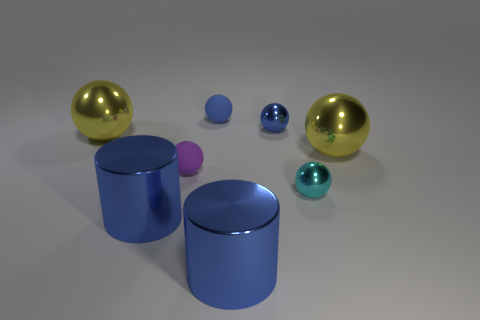Subtract 2 balls. How many balls are left? 4 Subtract all cyan spheres. How many spheres are left? 5 Subtract all blue balls. How many balls are left? 4 Subtract all gray balls. Subtract all blue blocks. How many balls are left? 6 Add 2 purple rubber things. How many objects exist? 10 Subtract all spheres. How many objects are left? 2 Subtract 1 blue balls. How many objects are left? 7 Subtract all large yellow objects. Subtract all shiny things. How many objects are left? 0 Add 1 cyan shiny spheres. How many cyan shiny spheres are left? 2 Add 4 cyan spheres. How many cyan spheres exist? 5 